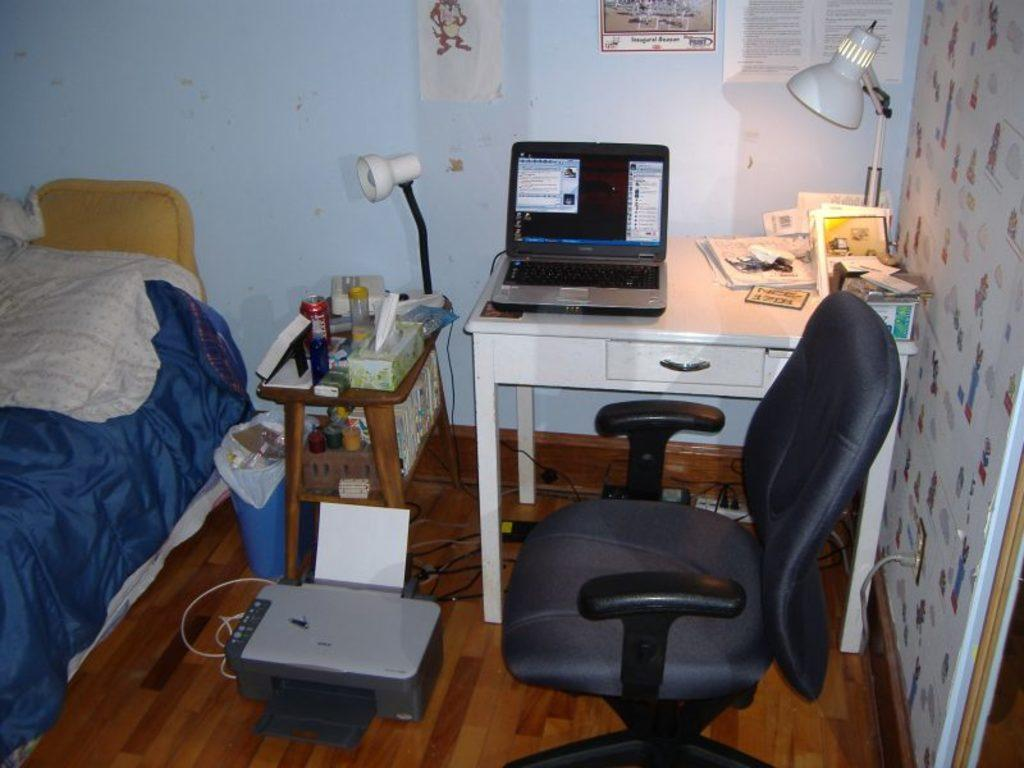What type of space is depicted in the image? There is a room in the image. What furniture is present in the room? There is a table, a chair, a cot, and a bed in the room. What is on the table in the room? There is a laptop on the table. What item is used for comfort while sleeping or resting? There is a pillow in the room. How many trees can be seen through the window in the room? There is no window or tree visible in the image. What type of truck is parked outside the room? There is no truck visible in the image. 